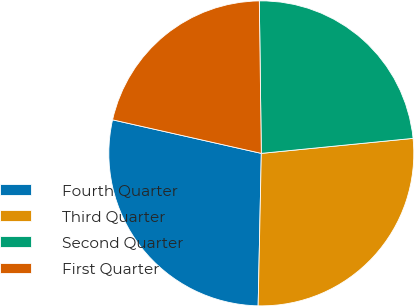Convert chart to OTSL. <chart><loc_0><loc_0><loc_500><loc_500><pie_chart><fcel>Fourth Quarter<fcel>Third Quarter<fcel>Second Quarter<fcel>First Quarter<nl><fcel>28.2%<fcel>26.9%<fcel>23.64%<fcel>21.26%<nl></chart> 